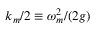Convert formula to latex. <formula><loc_0><loc_0><loc_500><loc_500>{ k _ { m } } / { 2 } \equiv \omega _ { m } ^ { 2 } / ( 2 g )</formula> 